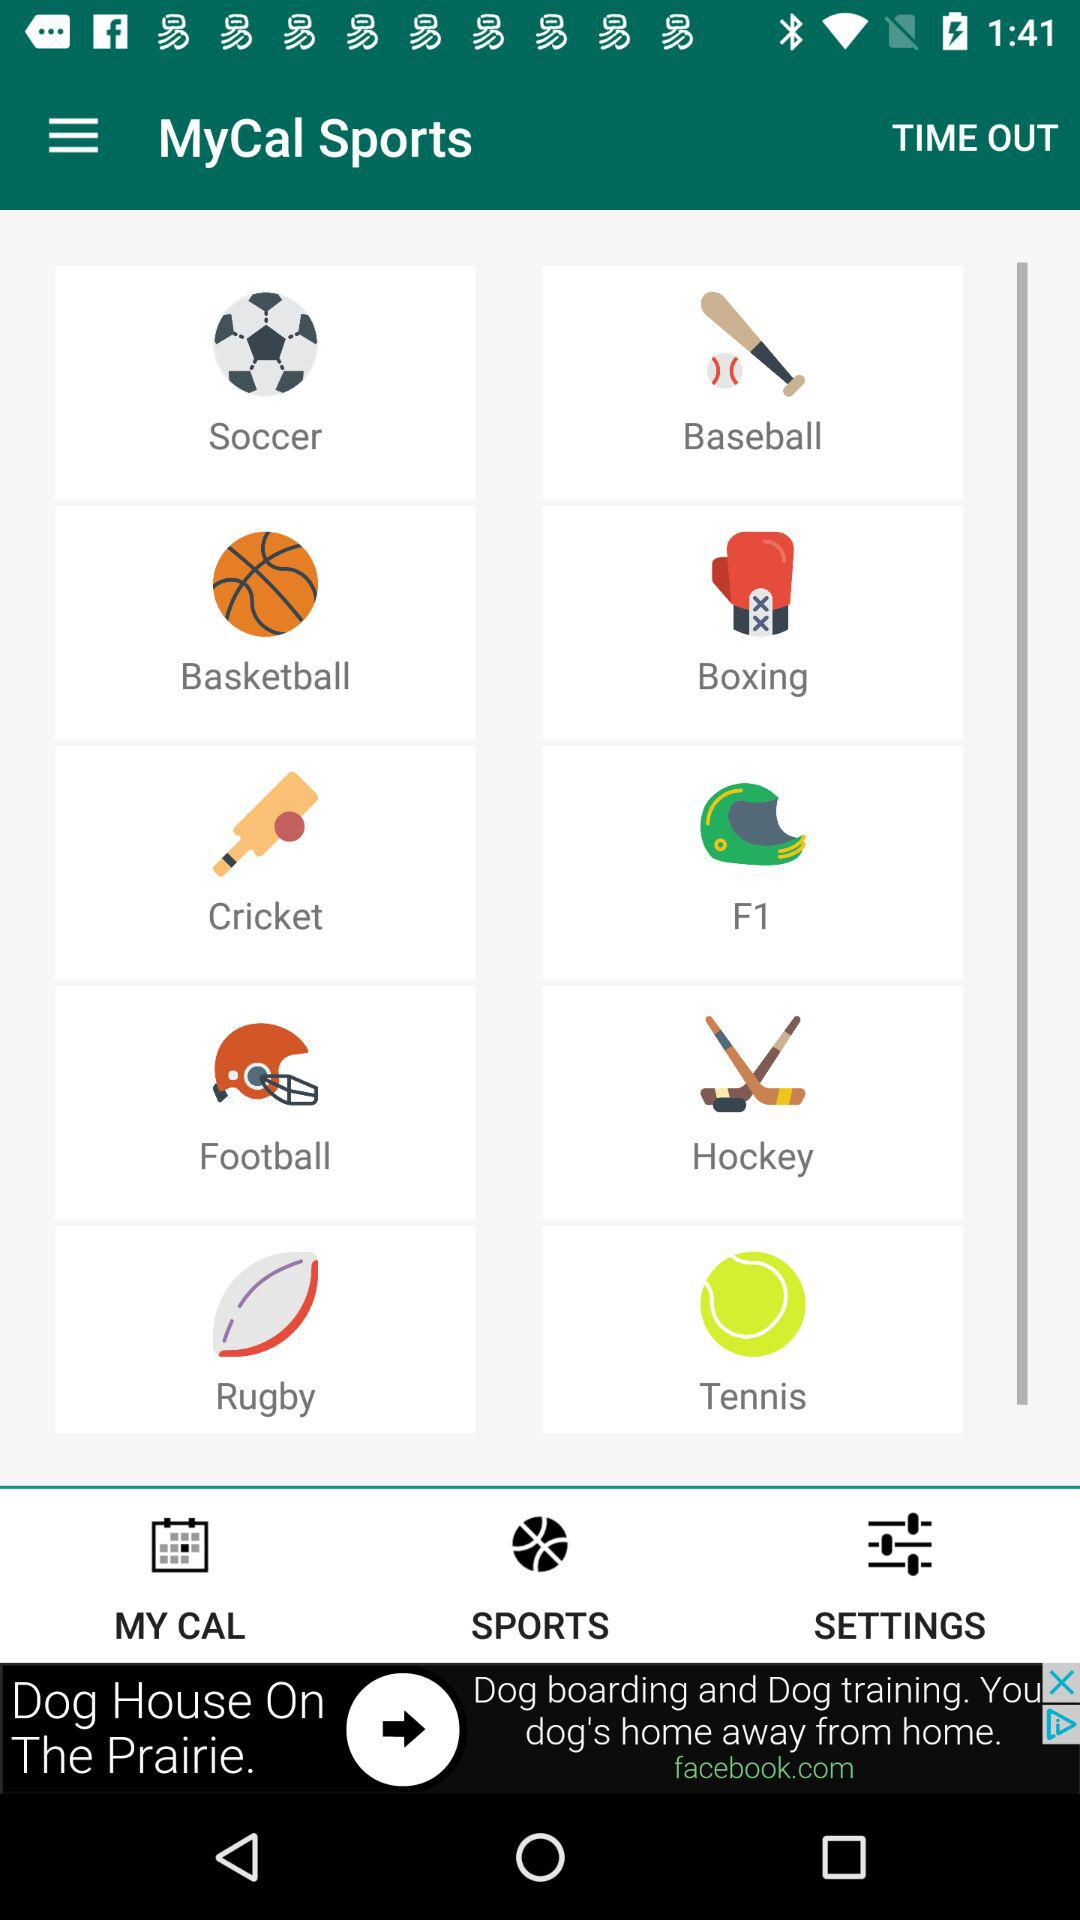What is the application name? The application name is "MyCal Sports". 